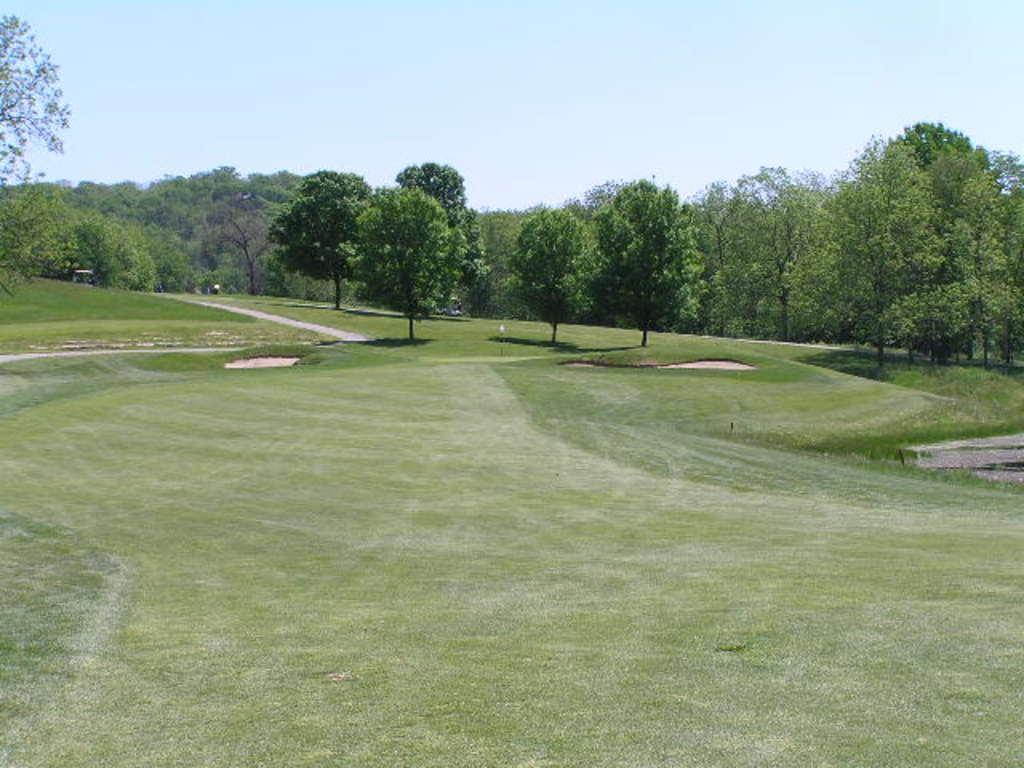Can you describe this image briefly? There is a golf ground in the image and there are many trees in the image. 